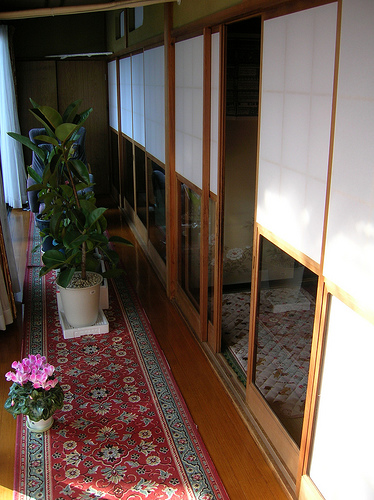<image>
Is the plant in the pot? Yes. The plant is contained within or inside the pot, showing a containment relationship. 